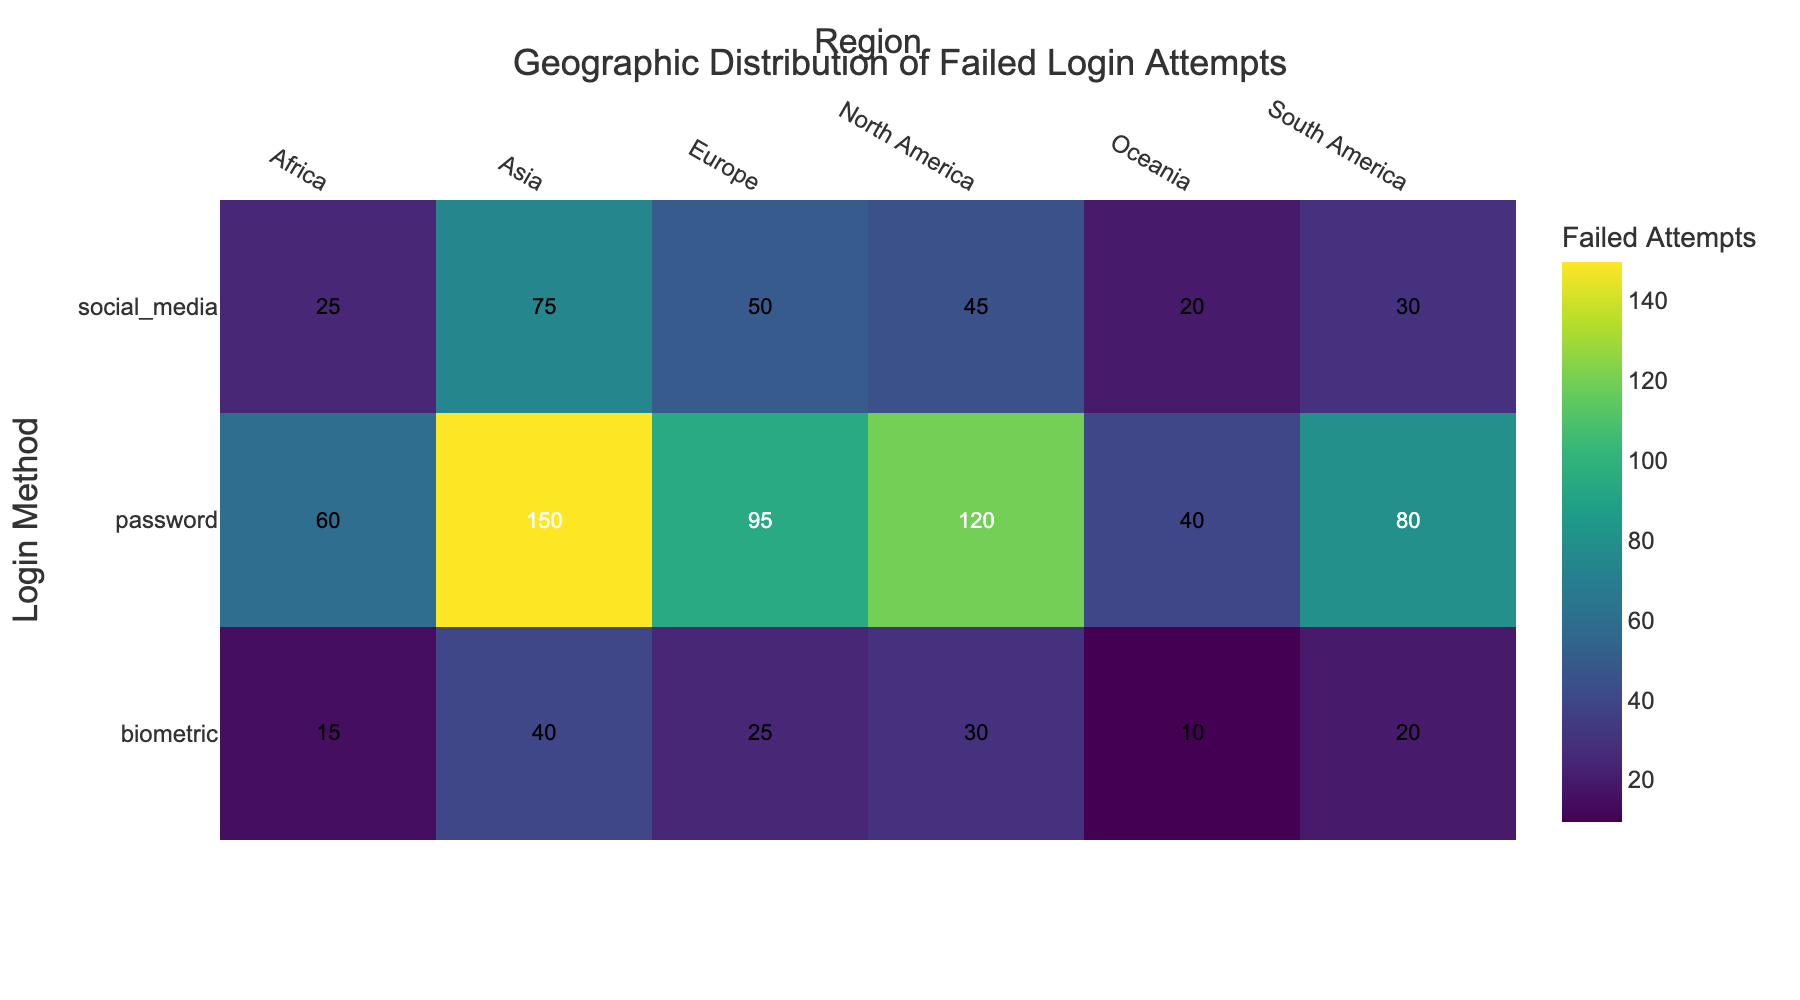Which region has the highest number of failed login attempts for the password method? By looking at the heatmap, we can see that Asia has the darkest color in the row corresponding to the password method, indicating the highest number of failed login attempts.
Answer: Asia Which login method had the least number of failed attempts in Africa? From the heatmap, we observe that the biometric method has the lightest color in the Africa column, suggesting the lowest number of failed attempts.
Answer: Biometric What is the total number of failed login attempts for social media across all regions? Sum the values for social media across all regions: 45 (North America) + 50 (Europe) + 75 (Asia) + 30 (South America) + 25 (Africa) + 20 (Oceania) = 245.
Answer: 245 How do the failed login attempts in Europe for biometrics compare to those in South America for the same method? The heatmap shows that Europe has 25 failed biometric attempts, while South America has 20. This means Europe has more failed attempts.
Answer: More in Europe Which login method has the most consistent distribution of failed attempts across regions? By evaluating the colors in each row, the colors for the biometric method are more uniform compared to password and social media, indicating a more consistent distribution of failed attempts across regions.
Answer: Biometric In which region is the difference between failed login attempts for password and social media the greatest? Subtract the number of failed attempts for social media from password for each region: North America (120 - 45 = 75), Europe (95 - 50 = 45), Asia (150 - 75 = 75), South America (80 - 30 = 50), Africa (60 - 25 = 35), Oceania (40 - 20 = 20). The greatest difference is in Asia and North America, both with a difference of 75.
Answer: Asia and North America What is the average number of failed login attempts for the biometric method across all regions? Sum the values for biometric across all regions and divide by the number of regions: (30 + 25 + 40 + 20 + 15 + 10) / 6 = 140 / 6 ≈ 23.33.
Answer: 23.33 Which region has the lowest total number of failed login attempts across all login methods? Sum the values for each region across all methods: North America (120+45+30=195), Europe (95+50+25=170), Asia (150+75+40=265), South America (80+30+20=130), Africa (60+25+15=100), Oceania (40+20+10=70). Oceania has the lowest total with 70 failed attempts.
Answer: Oceania 